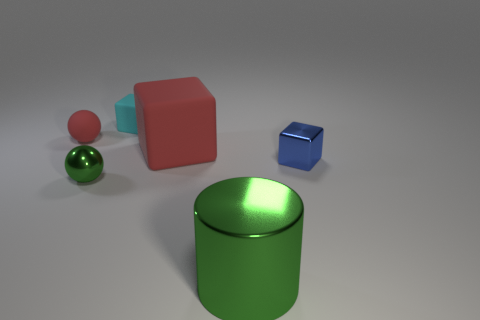Subtract all rubber blocks. How many blocks are left? 1 Subtract all spheres. How many objects are left? 4 Add 1 red objects. How many objects exist? 7 Subtract all cyan cubes. How many cubes are left? 2 Subtract 1 red spheres. How many objects are left? 5 Subtract 1 spheres. How many spheres are left? 1 Subtract all brown blocks. Subtract all purple balls. How many blocks are left? 3 Subtract all brown cubes. How many purple balls are left? 0 Subtract all big blue rubber objects. Subtract all small metallic objects. How many objects are left? 4 Add 1 small shiny cubes. How many small shiny cubes are left? 2 